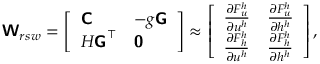<formula> <loc_0><loc_0><loc_500><loc_500>W _ { r s w } = \left [ \begin{array} { l l } { C } & { - g G } \\ { H G ^ { \top } } & { 0 } \end{array} \right ] \approx \left [ \begin{array} { l l } { \frac { \partial F _ { u } ^ { h } } { \partial u ^ { h } } } & { \frac { \partial F _ { u } ^ { h } } { \partial h ^ { h } } } \\ { \frac { \partial F _ { h } ^ { h } } { \partial u ^ { h } } } & { \frac { \partial F _ { h } ^ { h } } { \partial h ^ { h } } } \end{array} \right ] ,</formula> 